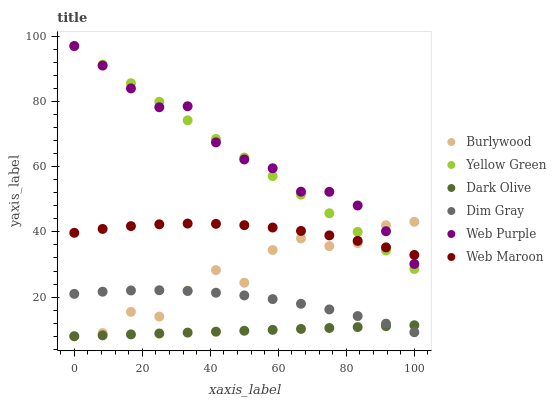Does Dark Olive have the minimum area under the curve?
Answer yes or no. Yes. Does Web Purple have the maximum area under the curve?
Answer yes or no. Yes. Does Yellow Green have the minimum area under the curve?
Answer yes or no. No. Does Yellow Green have the maximum area under the curve?
Answer yes or no. No. Is Dark Olive the smoothest?
Answer yes or no. Yes. Is Burlywood the roughest?
Answer yes or no. Yes. Is Yellow Green the smoothest?
Answer yes or no. No. Is Yellow Green the roughest?
Answer yes or no. No. Does Burlywood have the lowest value?
Answer yes or no. Yes. Does Yellow Green have the lowest value?
Answer yes or no. No. Does Web Purple have the highest value?
Answer yes or no. Yes. Does Burlywood have the highest value?
Answer yes or no. No. Is Dark Olive less than Web Maroon?
Answer yes or no. Yes. Is Yellow Green greater than Dim Gray?
Answer yes or no. Yes. Does Yellow Green intersect Burlywood?
Answer yes or no. Yes. Is Yellow Green less than Burlywood?
Answer yes or no. No. Is Yellow Green greater than Burlywood?
Answer yes or no. No. Does Dark Olive intersect Web Maroon?
Answer yes or no. No. 